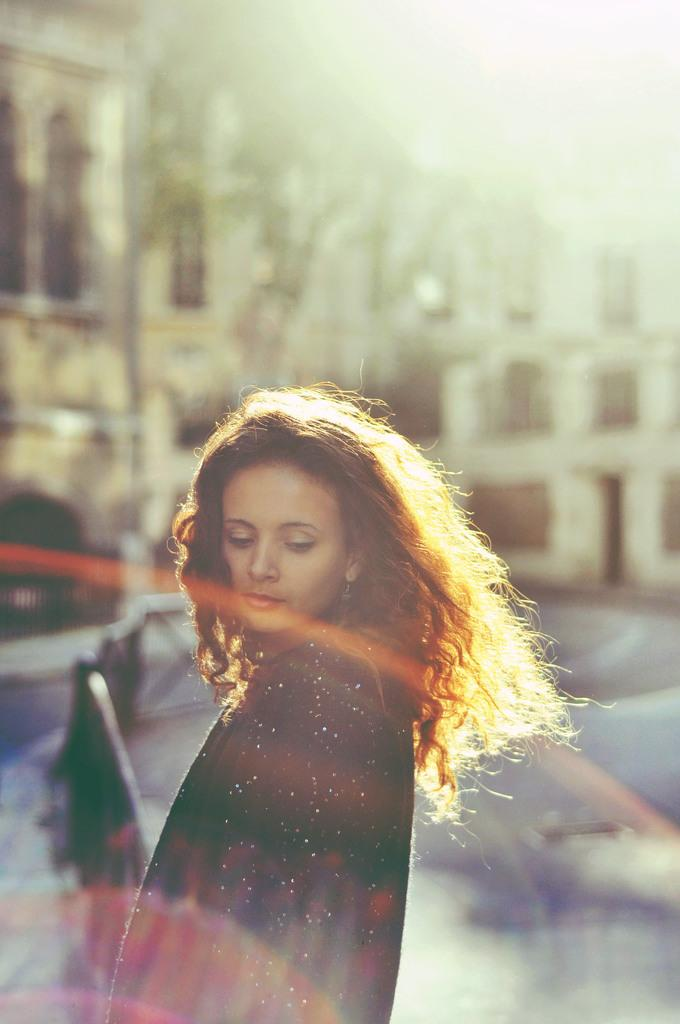Who is present in the image? There is a woman in the image. What can be seen in the background of the image? There is a building in the background of the image. What type of berry can be smelled in the image? There is no berry present in the image, and therefore no scent can be associated with it. Is there a zebra visible in the image? No, there is no zebra present in the image. 